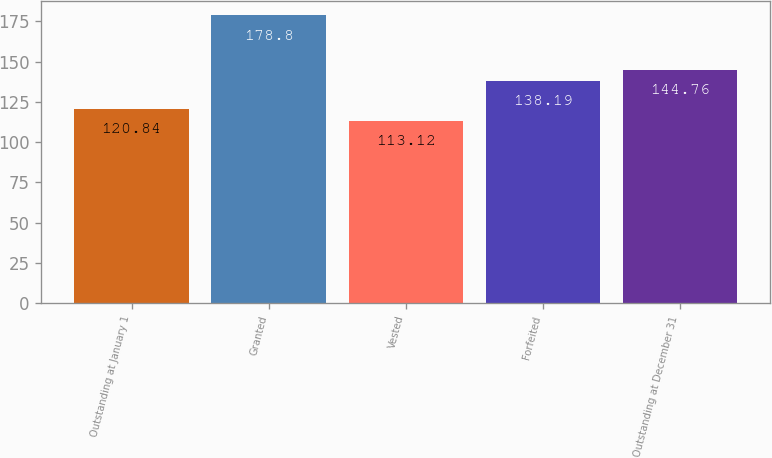Convert chart to OTSL. <chart><loc_0><loc_0><loc_500><loc_500><bar_chart><fcel>Outstanding at January 1<fcel>Granted<fcel>Vested<fcel>Forfeited<fcel>Outstanding at December 31<nl><fcel>120.84<fcel>178.8<fcel>113.12<fcel>138.19<fcel>144.76<nl></chart> 